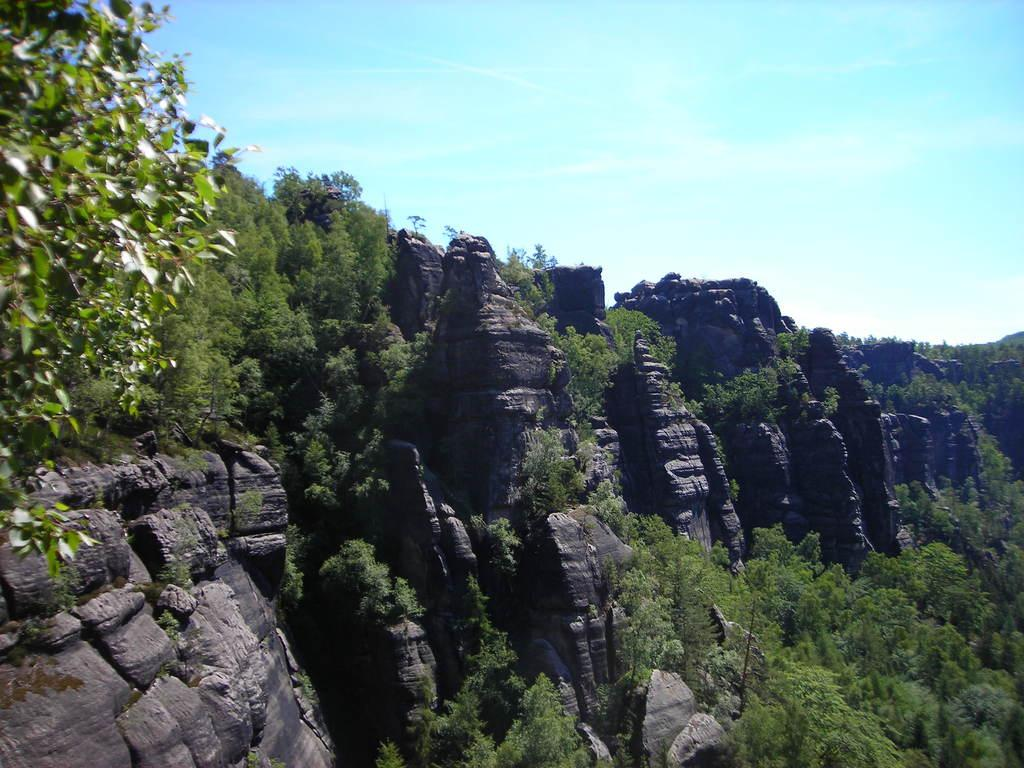What type of geographical feature is present in the image? There are huge hills in the image. What can be seen growing or thriving between the hills? There are many plants in between the hills. What type of skin condition can be seen on the hills in the image? There is no skin condition present on the hills in the image; they are geographical features. Is there any quicksand visible in the image? There is no quicksand present in the image. Are there any jellyfish visible in the image? There are no jellyfish present in the image, as it features hills and plants. 